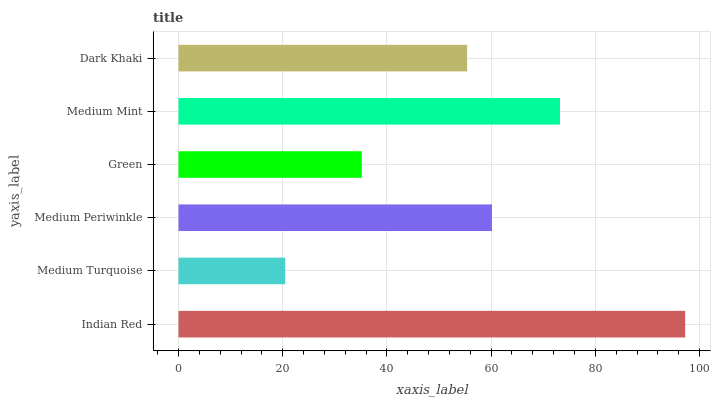Is Medium Turquoise the minimum?
Answer yes or no. Yes. Is Indian Red the maximum?
Answer yes or no. Yes. Is Medium Periwinkle the minimum?
Answer yes or no. No. Is Medium Periwinkle the maximum?
Answer yes or no. No. Is Medium Periwinkle greater than Medium Turquoise?
Answer yes or no. Yes. Is Medium Turquoise less than Medium Periwinkle?
Answer yes or no. Yes. Is Medium Turquoise greater than Medium Periwinkle?
Answer yes or no. No. Is Medium Periwinkle less than Medium Turquoise?
Answer yes or no. No. Is Medium Periwinkle the high median?
Answer yes or no. Yes. Is Dark Khaki the low median?
Answer yes or no. Yes. Is Dark Khaki the high median?
Answer yes or no. No. Is Medium Mint the low median?
Answer yes or no. No. 